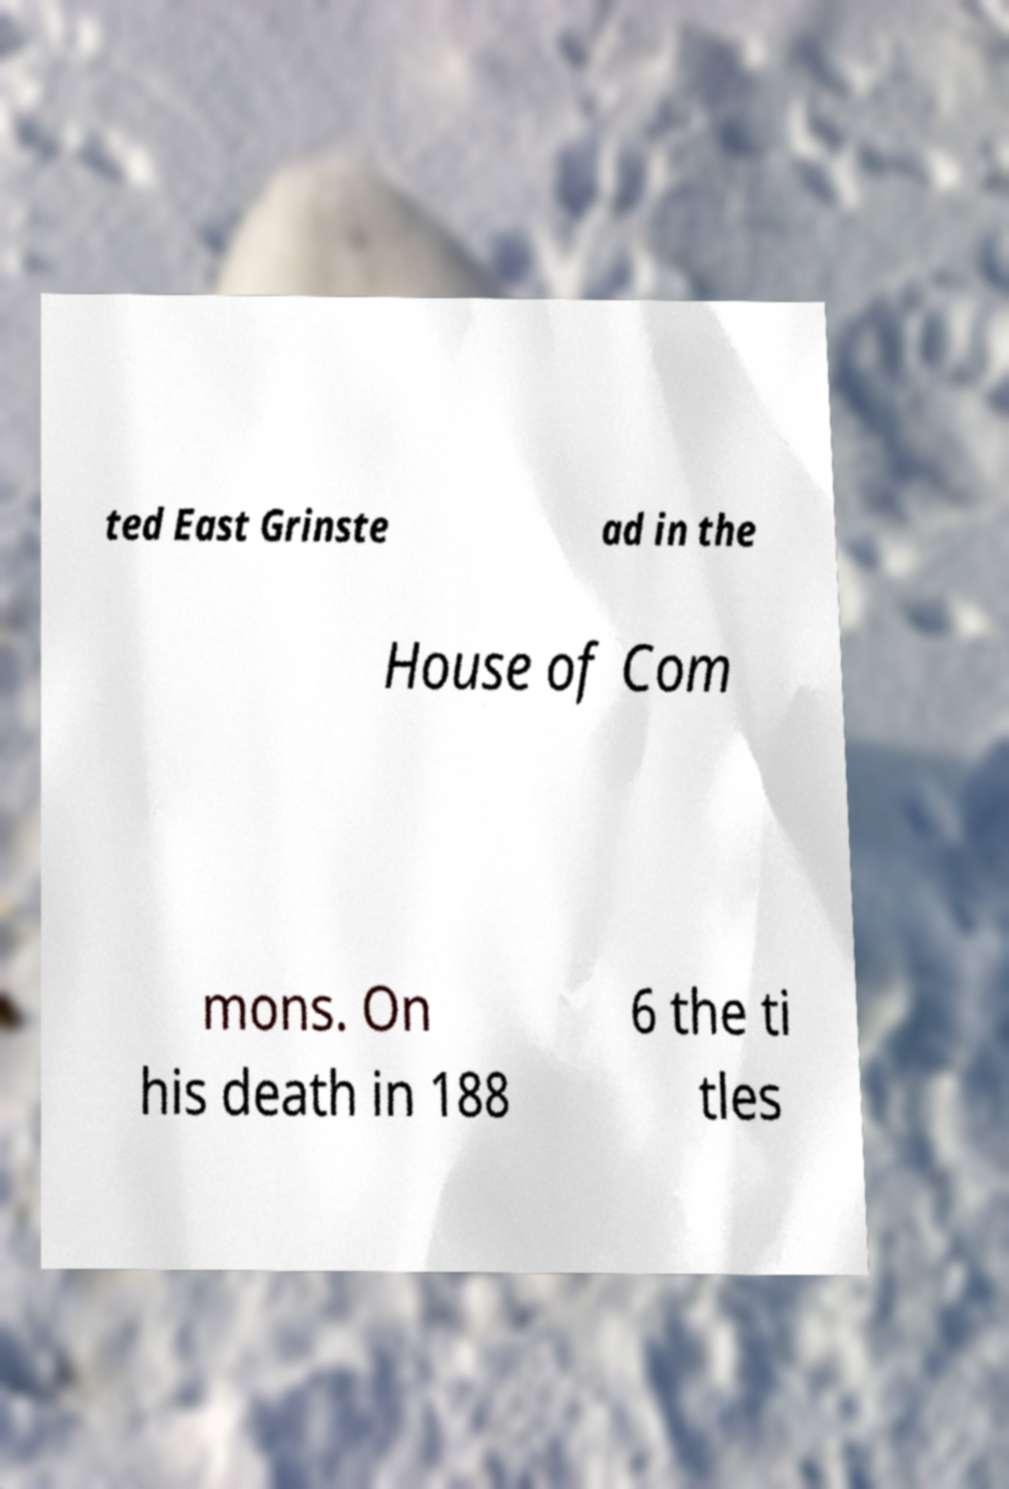Please identify and transcribe the text found in this image. ted East Grinste ad in the House of Com mons. On his death in 188 6 the ti tles 